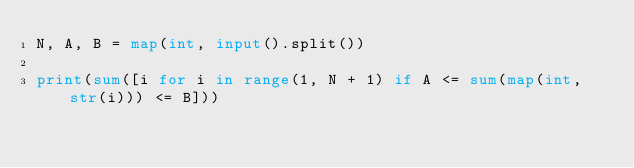<code> <loc_0><loc_0><loc_500><loc_500><_Python_>N, A, B = map(int, input().split())

print(sum([i for i in range(1, N + 1) if A <= sum(map(int, str(i))) <= B]))
</code> 